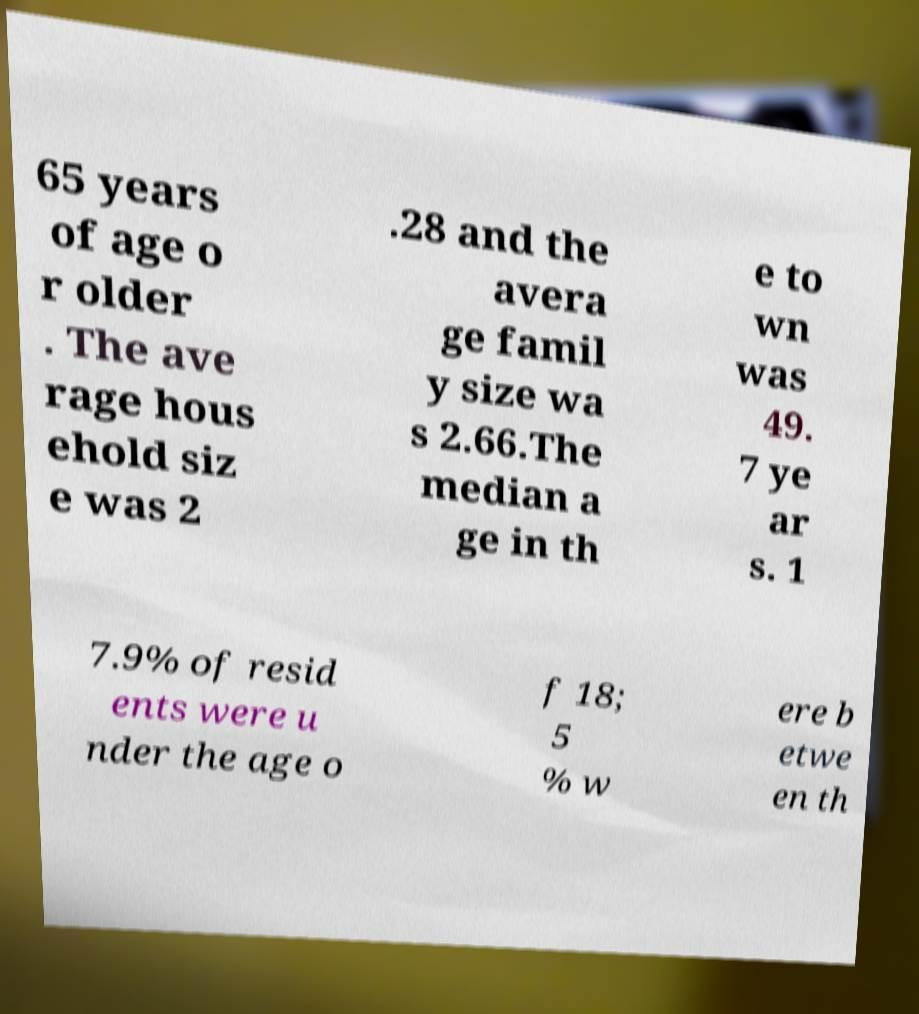Please identify and transcribe the text found in this image. 65 years of age o r older . The ave rage hous ehold siz e was 2 .28 and the avera ge famil y size wa s 2.66.The median a ge in th e to wn was 49. 7 ye ar s. 1 7.9% of resid ents were u nder the age o f 18; 5 % w ere b etwe en th 